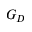<formula> <loc_0><loc_0><loc_500><loc_500>G _ { D }</formula> 